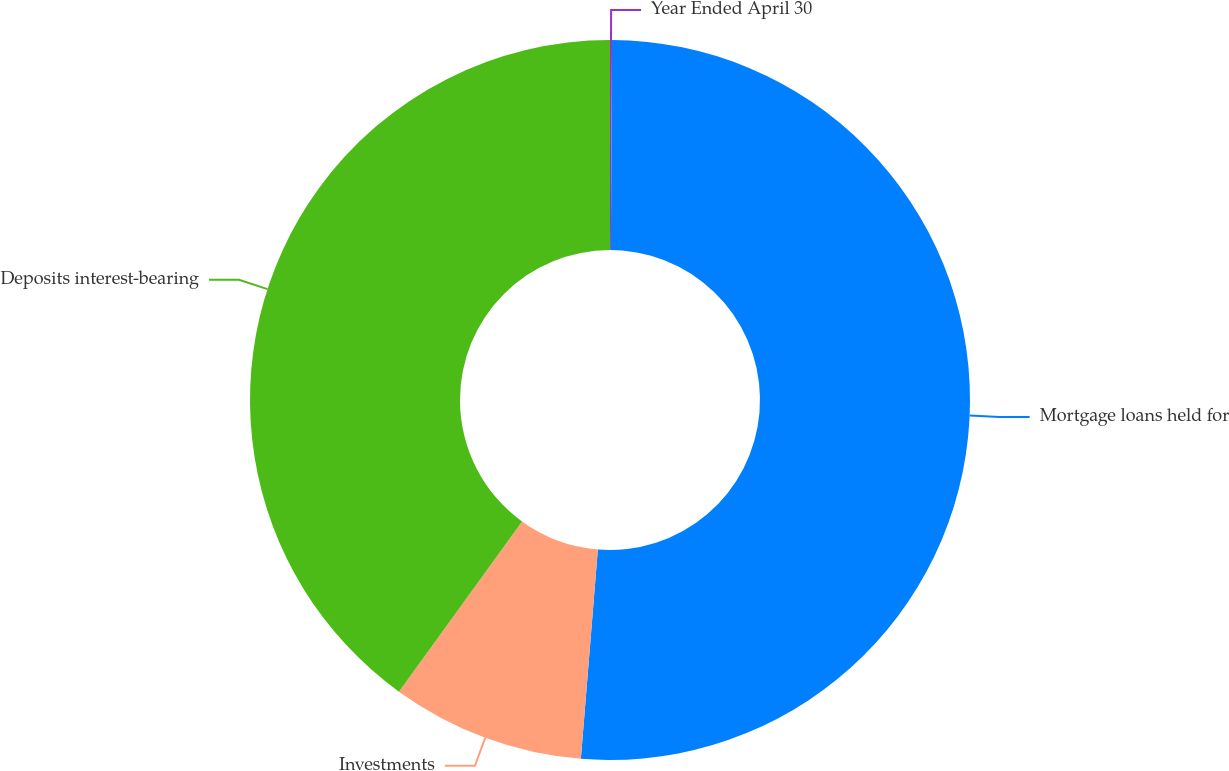Convert chart to OTSL. <chart><loc_0><loc_0><loc_500><loc_500><pie_chart><fcel>Year Ended April 30<fcel>Mortgage loans held for<fcel>Investments<fcel>Deposits interest-bearing<nl><fcel>0.09%<fcel>51.2%<fcel>8.68%<fcel>40.03%<nl></chart> 